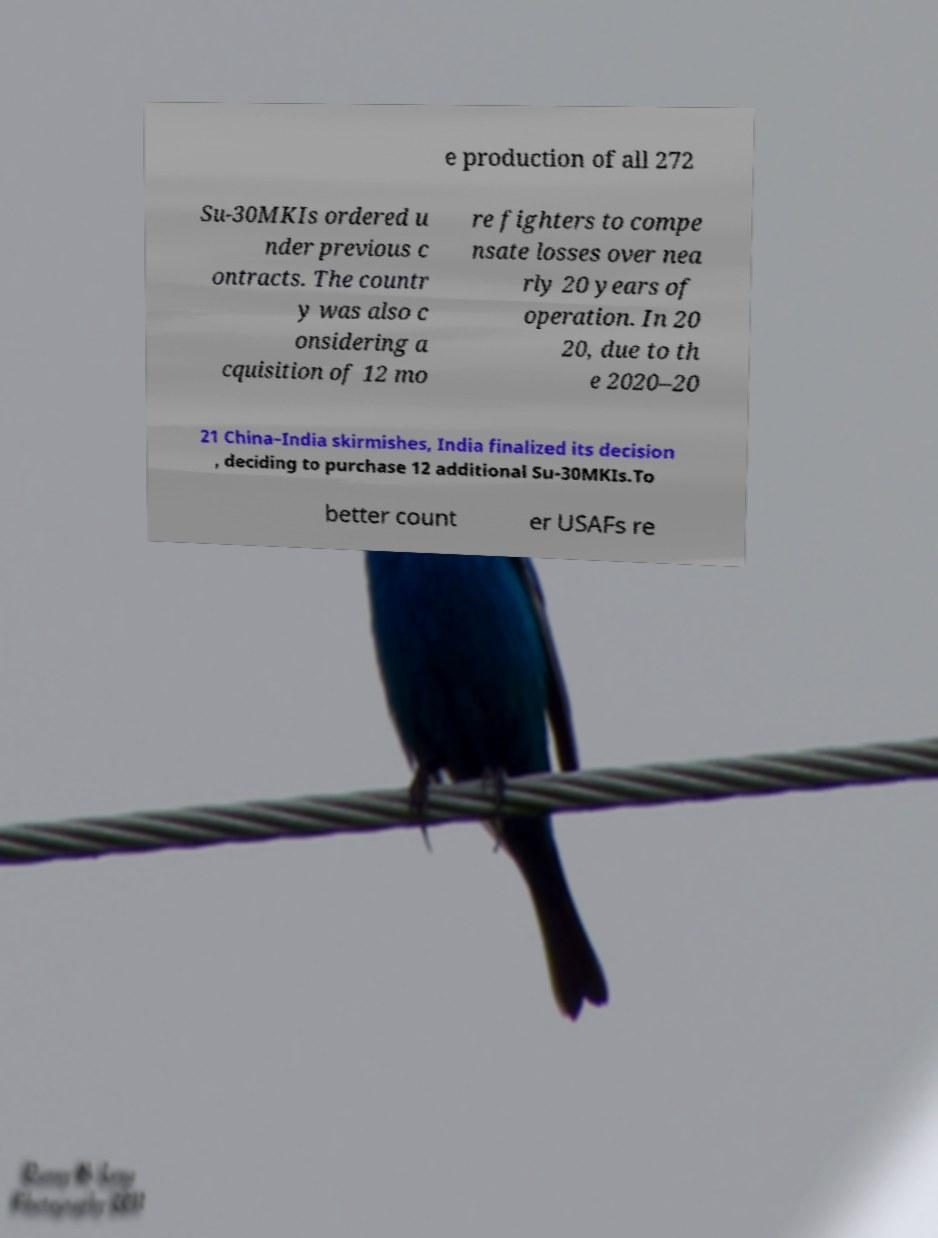For documentation purposes, I need the text within this image transcribed. Could you provide that? e production of all 272 Su-30MKIs ordered u nder previous c ontracts. The countr y was also c onsidering a cquisition of 12 mo re fighters to compe nsate losses over nea rly 20 years of operation. In 20 20, due to th e 2020–20 21 China–India skirmishes, India finalized its decision , deciding to purchase 12 additional Su-30MKIs.To better count er USAFs re 